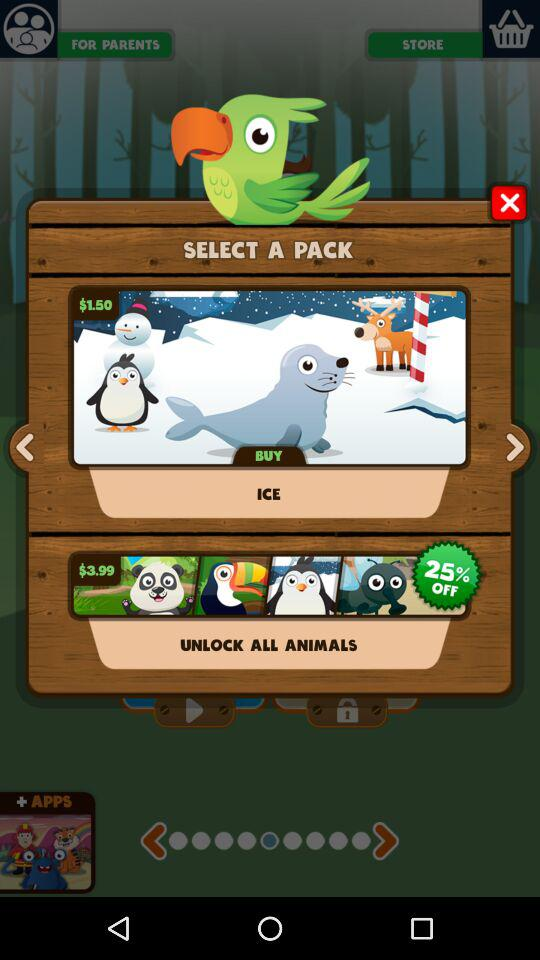How much discount is available on the pack "UNLOCK ALL ANIMALS"? The discount available on the pack "UNLOCK ALL ANIMALS" is 25%. 